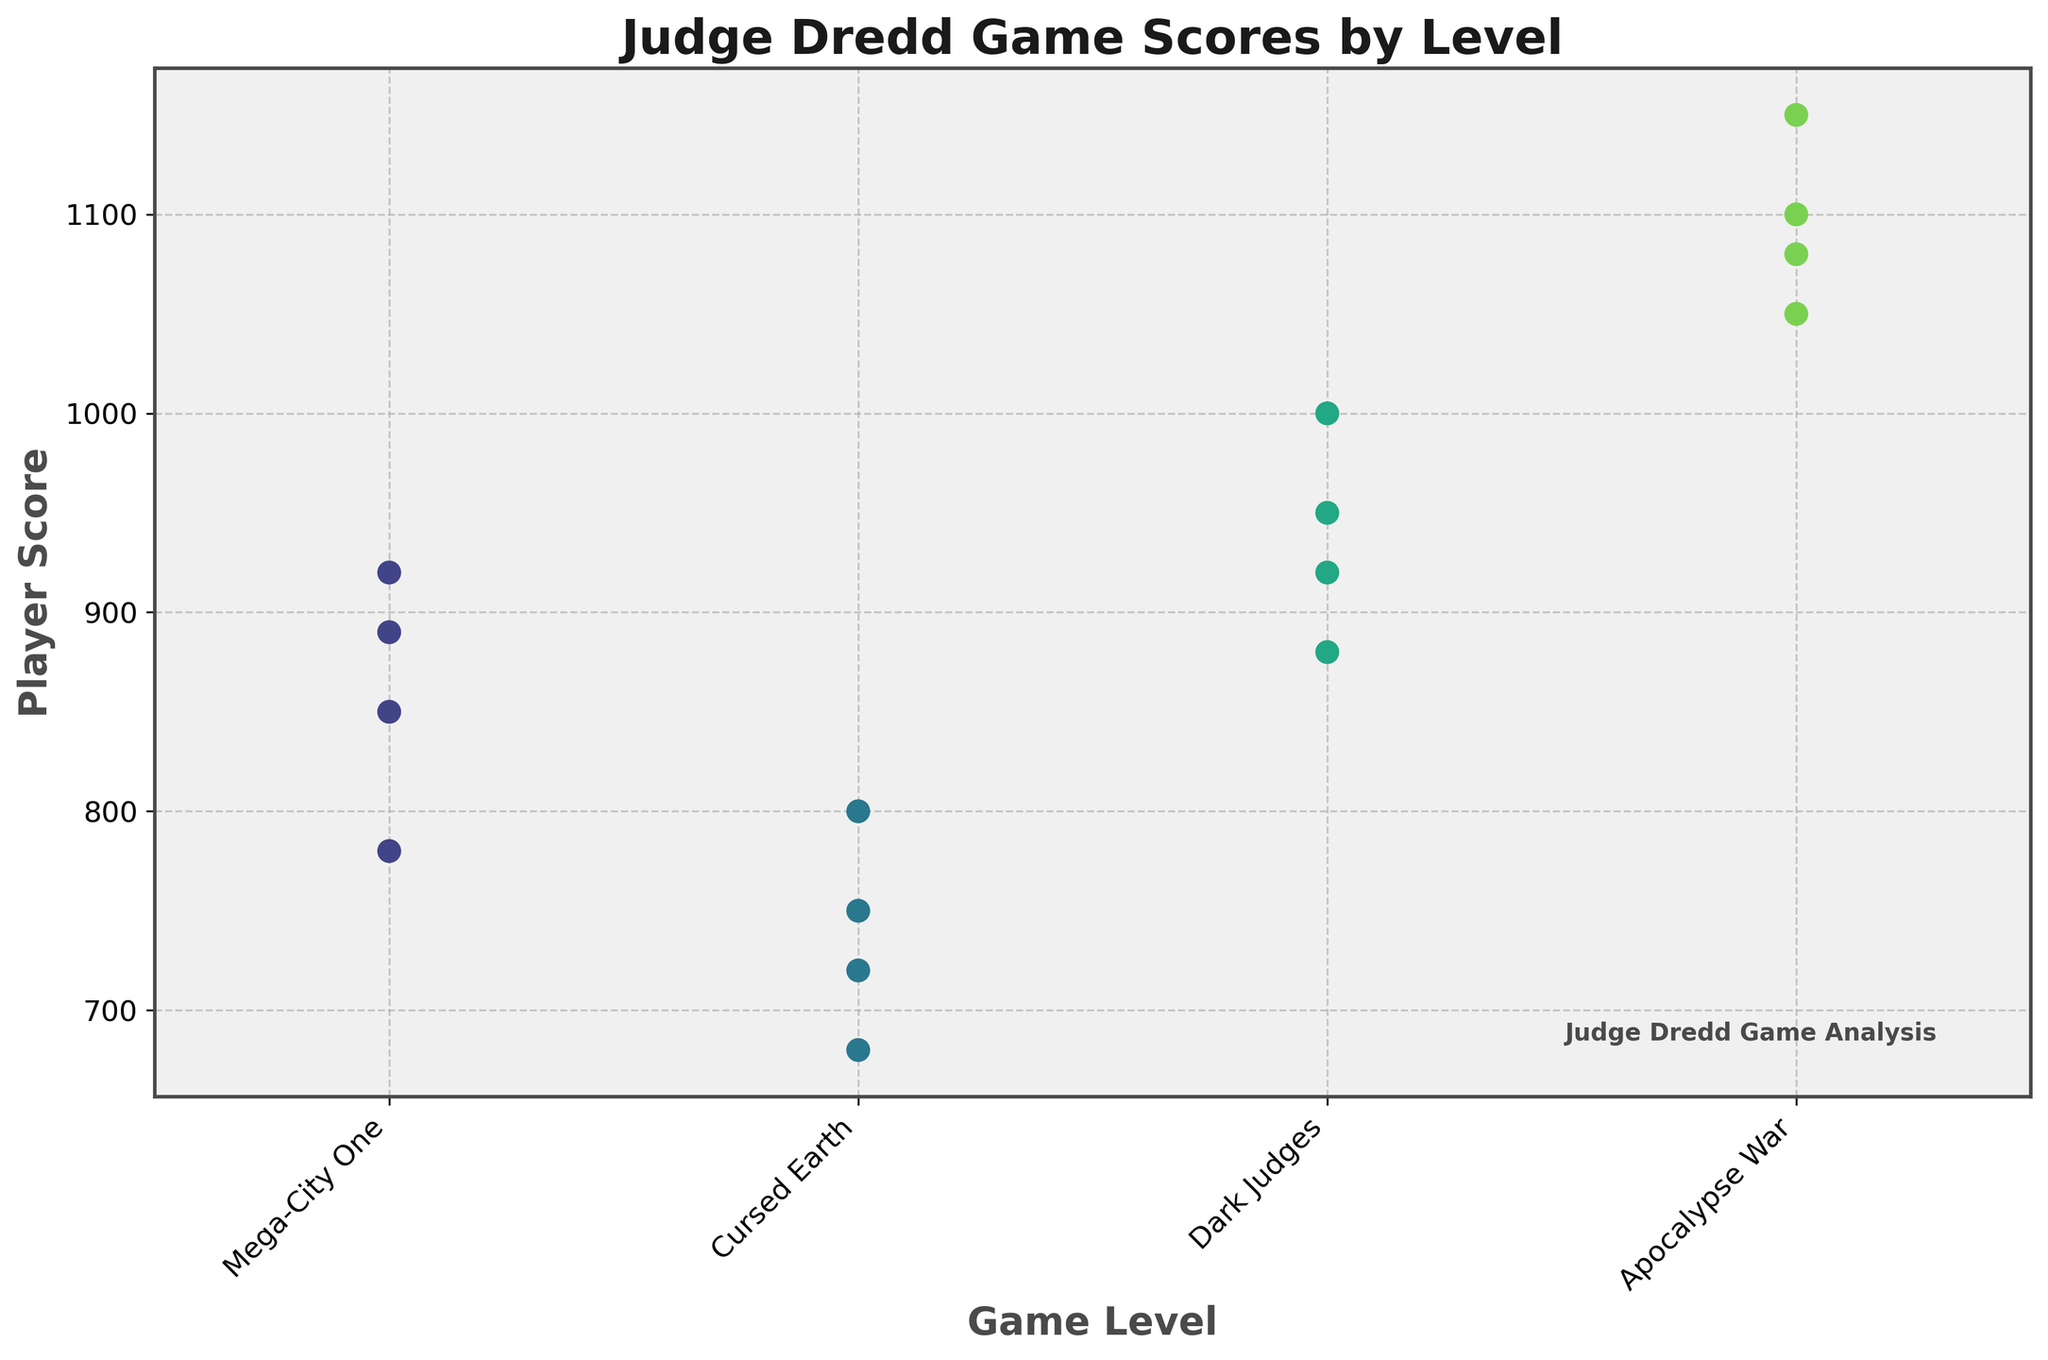What is the title of the plot? The title is displayed at the top of the plot. It summarizes the contents of the figure in a concise manner. It's useful to identify the context at a quick glance.
Answer: Judge Dredd Game Scores by Level How many levels are displayed on the x-axis? The x-axis categorizes the data by different levels in the game. Each category represents a distinct level in the Judge Dredd game.
Answer: 4 Which player scored the highest in the 'Apocalypse War' level? By looking at the swarm plot under the 'Apocalypse War' level category on the x-axis, we can identify the highest point which represents the player with the highest score in that specific level.
Answer: JudgeAnderson Which level has the most concentrated scores? Observing the spread of data points (scores) for each level on the x-axis, the level with data points densely packed together indicates the most concentration of scores.
Answer: Dark Judges What's the range of scores in 'Mega-City One'? To find the range, identify the maximum and minimum scores for the 'Mega-City One' level. Subtract the minimum score from the maximum score.
Answer: 140 Which level shows the widest spread in player scores? To determine the widest spread, observe the vertical spread of data points for each level. The level with the greatest vertical distance between the highest and lowest points shows the widest spread.
Answer: Apocalypse War Compare the median score of 'Cursed Earth' with that of 'Dark Judges'. Which is higher? Identify the middle value of the scores for each level. The median score represents the data point in the middle of a sorted list. Compare the median scores of 'Cursed Earth' and 'Dark Judges'.
Answer: Dark Judges Are there any outlier scores in 'Mega-City One'? An outlier score in bee swarm plots often appears visually separated from the dense cluster of other scores. Look for any data point that is noticeably distant from the rest in 'Mega-City One'.
Answer: No Which player consistently improves their score from 'Mega-City One' to 'Apocalypse War'? Trace the scores of each player across the various levels. The player who shows an increasing trend in their scores from 'Mega-City One' to 'Apocalypse War' is considered consistent in improvement.
Answer: JudgeAnderson 